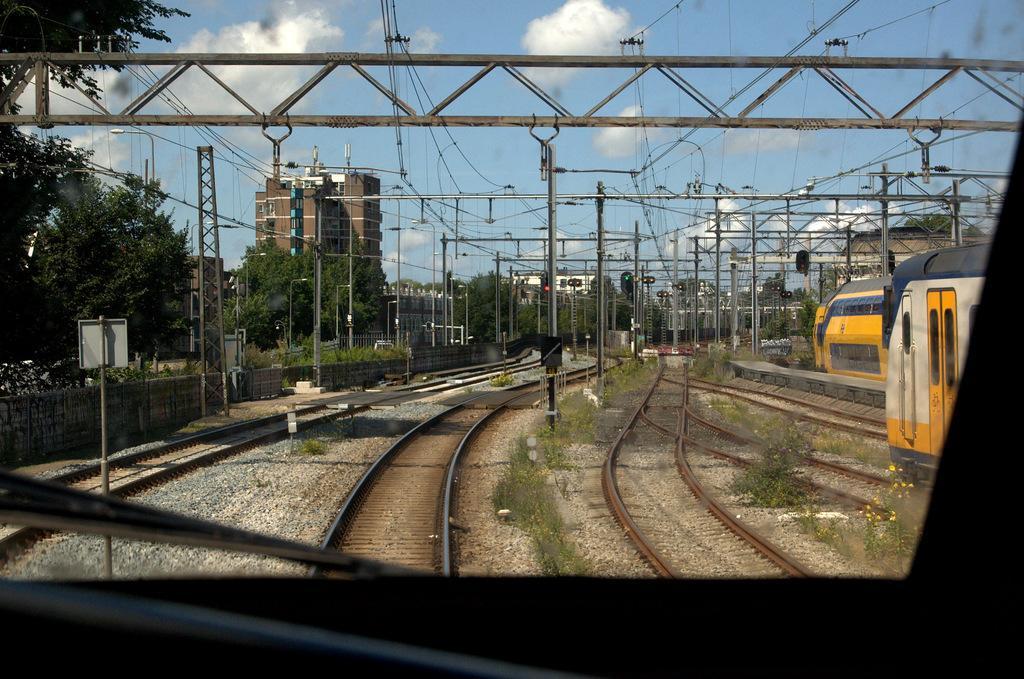How would you summarize this image in a sentence or two? In this image we can see trains, railway tracks, poles, traffic signals, tower, wall, plants, trees, and buildings. In the background there is sky with clouds. 